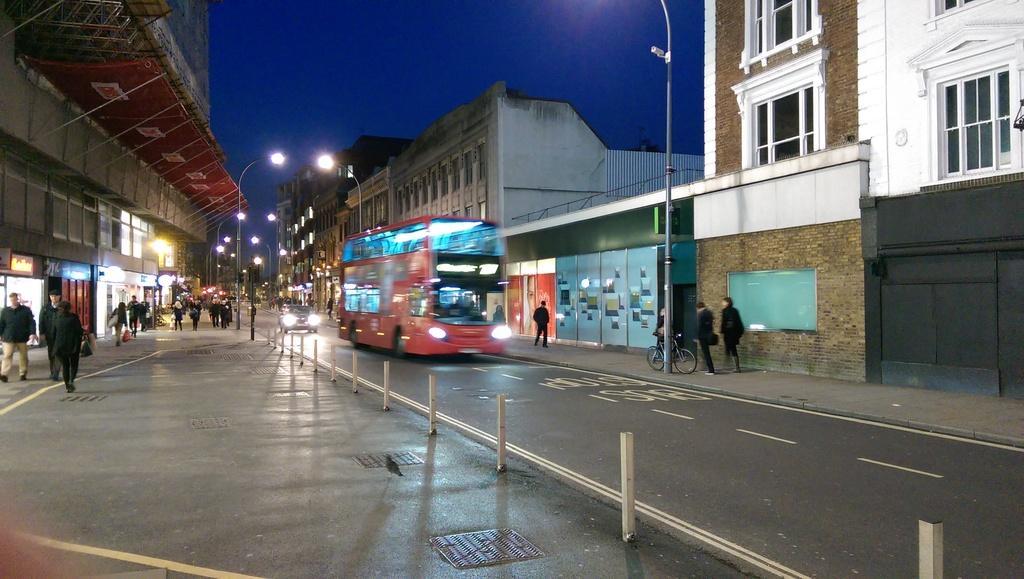How would you summarize this image in a sentence or two? In this picture I can see there is a bus moving on the road and there is a car here behind the bus and there are some people walking on the walk way and there are some street lights and there are buildings and the sky is clear. 